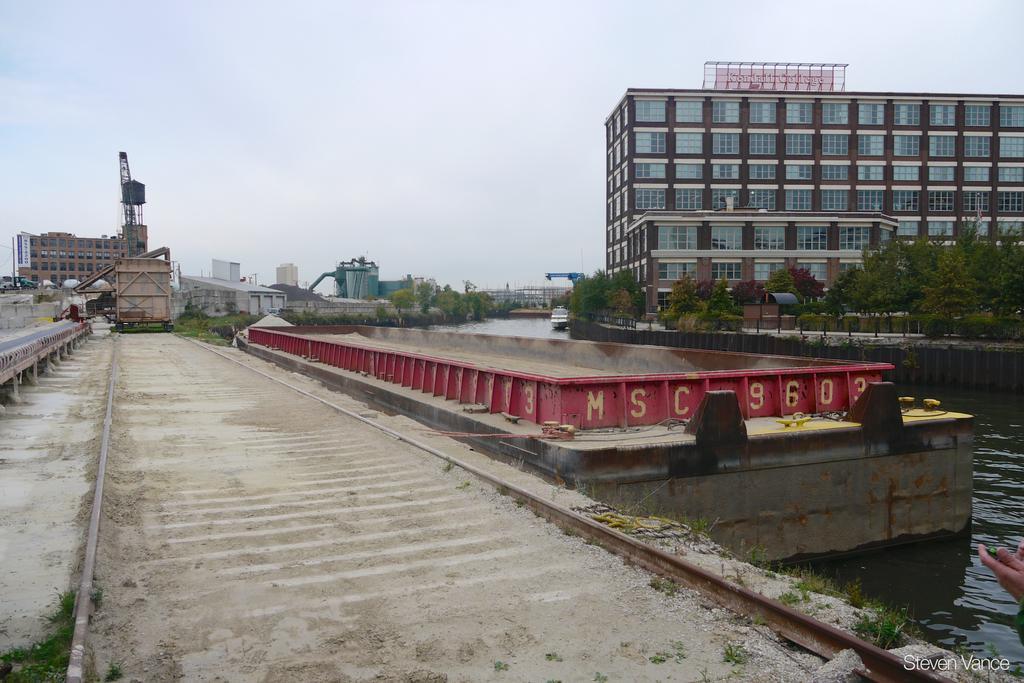Describe this image in one or two sentences. In this image I can see the track. To the right I can see the human hand and the water. I can also see many trees. In the background I can see the vehicle, many buildings and the sky. 